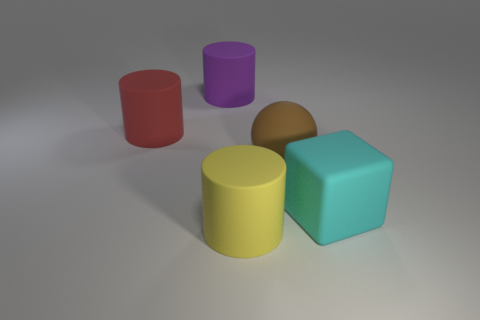Subtract all yellow cylinders. How many cylinders are left? 2 Add 4 cylinders. How many objects exist? 9 Subtract all yellow cylinders. How many cylinders are left? 2 Subtract 1 cyan cubes. How many objects are left? 4 Subtract all cylinders. How many objects are left? 2 Subtract all brown cubes. Subtract all cyan spheres. How many cubes are left? 1 Subtract all gray blocks. How many purple cylinders are left? 1 Subtract all large purple rubber objects. Subtract all large brown rubber things. How many objects are left? 3 Add 1 yellow rubber cylinders. How many yellow rubber cylinders are left? 2 Add 1 small yellow cylinders. How many small yellow cylinders exist? 1 